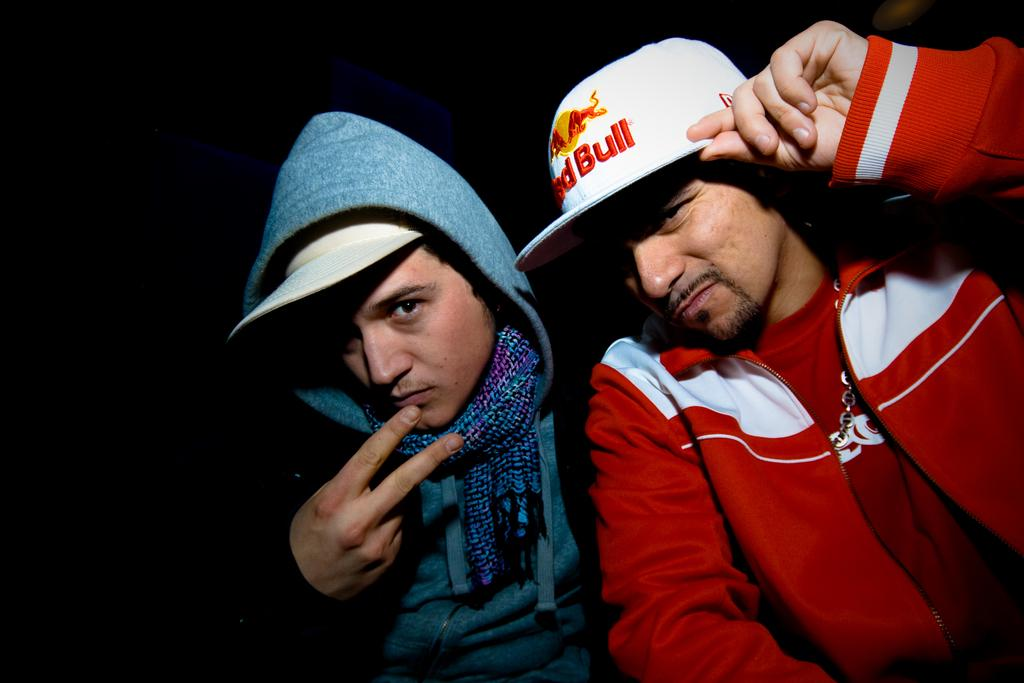<image>
Present a compact description of the photo's key features. A white Red bull branded cap is being worn by a man in a red sweater. 